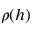<formula> <loc_0><loc_0><loc_500><loc_500>\rho ( h )</formula> 